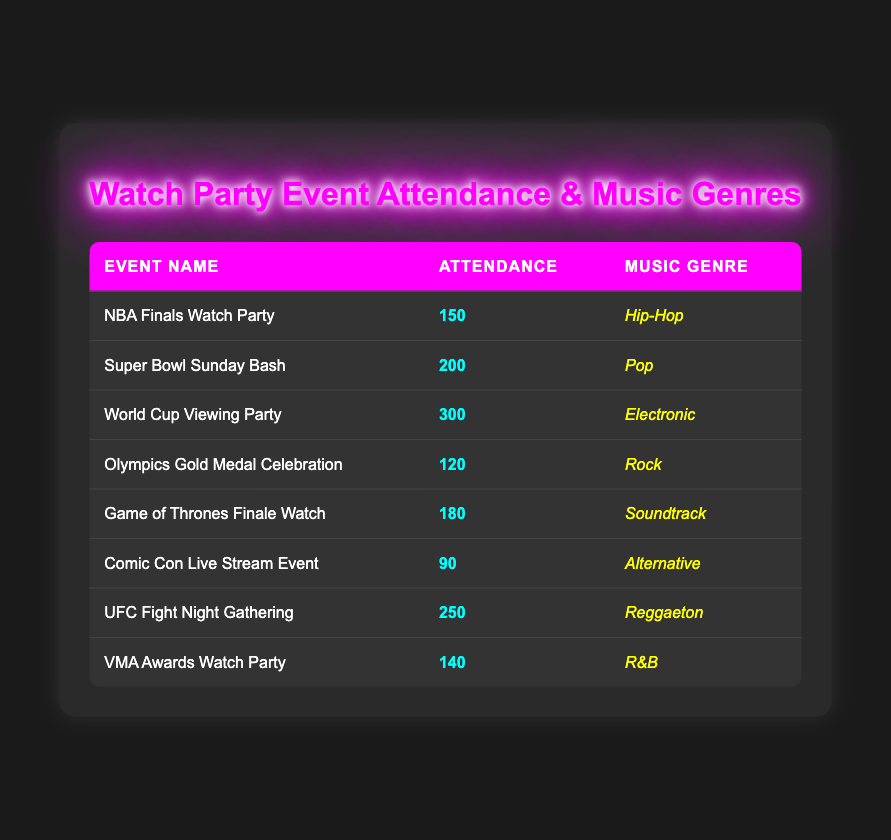What is the event with the highest attendance? The table lists the attendance for each event. Looking through the attendance column, the highest value is 300 for the "World Cup Viewing Party."
Answer: World Cup Viewing Party Which music genre was played at the Super Bowl Sunday Bash? The table shows the music genre corresponding to each event. For the "Super Bowl Sunday Bash," the music genre is "Pop."
Answer: Pop How many attendees were there at the UFC Fight Night Gathering? By scanning the attendance column, I see the "UFC Fight Night Gathering" has an attendance of 250.
Answer: 250 What is the average attendance across all events? To find the average, sum all attendance values: 150 + 200 + 300 + 120 + 180 + 90 + 250 + 140 = 1430. There are 8 events, so the average is 1430/8 = 178.75.
Answer: 178.75 Is there an event with attendance over 200? Reviewing the attendance data, both "Super Bowl Sunday Bash" and "World Cup Viewing Party" have attendance figures above 200. Therefore, the answer is yes.
Answer: Yes Which music genre is associated with the lowest attended event? The lowest attendance is 90 for the "Comic Con Live Stream Event." Checking the genre for this event, it is "Alternative."
Answer: Alternative What is the difference in attendance between the World Cup Viewing Party and the Olympics Gold Medal Celebration? The World Cup Viewing Party has 300 attendees, and the Olympics Gold Medal Celebration has 120 attendees. Subtracting these gives us 300 - 120 = 180.
Answer: 180 How many events featured R&B or Hip-Hop music genres? There are two events corresponding to those genres: "NBA Finals Watch Party" (Hip-Hop) and "VMA Awards Watch Party" (R&B), totaling to 2 events.
Answer: 2 What percentage of the total attendance does the World Cup Viewing Party represent? First, sum the total attendance from earlier (1430). The World Cup Viewing Party has 300 attendees, so the percentage is (300/1430) * 100 = 20.98%.
Answer: 20.98% 